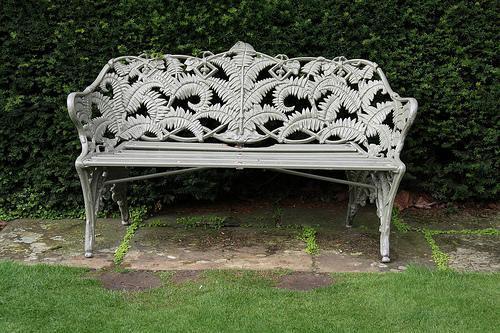How many benches are there?
Give a very brief answer. 1. 